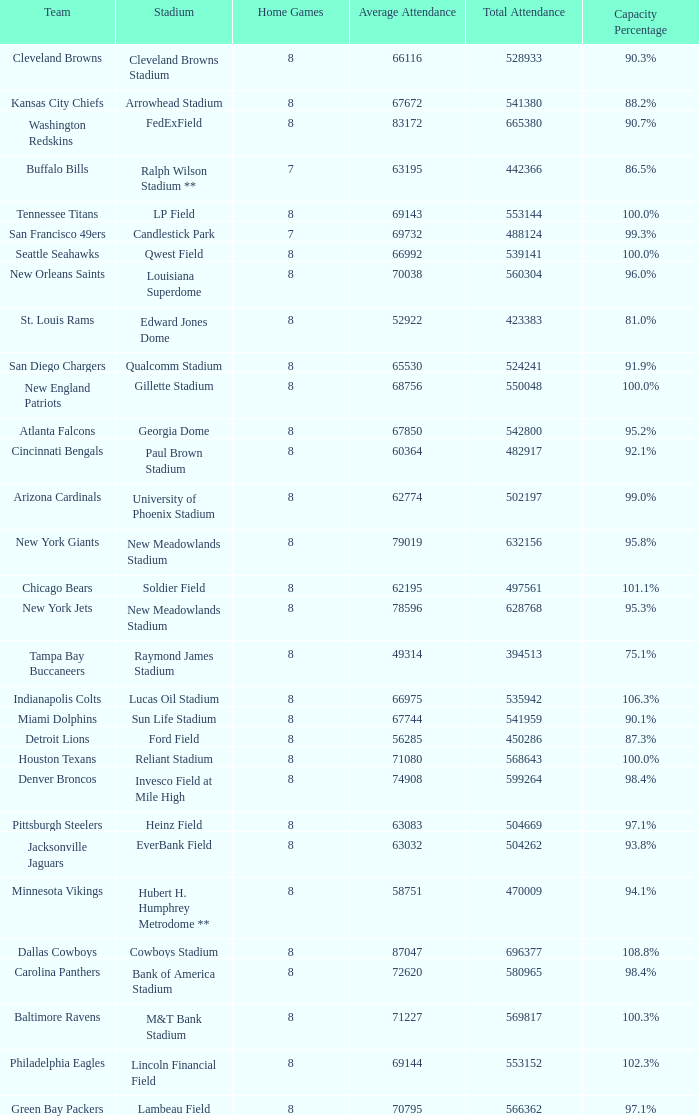Could you help me parse every detail presented in this table? {'header': ['Team', 'Stadium', 'Home Games', 'Average Attendance', 'Total Attendance', 'Capacity Percentage'], 'rows': [['Cleveland Browns', 'Cleveland Browns Stadium', '8', '66116', '528933', '90.3%'], ['Kansas City Chiefs', 'Arrowhead Stadium', '8', '67672', '541380', '88.2%'], ['Washington Redskins', 'FedExField', '8', '83172', '665380', '90.7%'], ['Buffalo Bills', 'Ralph Wilson Stadium **', '7', '63195', '442366', '86.5%'], ['Tennessee Titans', 'LP Field', '8', '69143', '553144', '100.0%'], ['San Francisco 49ers', 'Candlestick Park', '7', '69732', '488124', '99.3%'], ['Seattle Seahawks', 'Qwest Field', '8', '66992', '539141', '100.0%'], ['New Orleans Saints', 'Louisiana Superdome', '8', '70038', '560304', '96.0%'], ['St. Louis Rams', 'Edward Jones Dome', '8', '52922', '423383', '81.0%'], ['San Diego Chargers', 'Qualcomm Stadium', '8', '65530', '524241', '91.9%'], ['New England Patriots', 'Gillette Stadium', '8', '68756', '550048', '100.0%'], ['Atlanta Falcons', 'Georgia Dome', '8', '67850', '542800', '95.2%'], ['Cincinnati Bengals', 'Paul Brown Stadium', '8', '60364', '482917', '92.1%'], ['Arizona Cardinals', 'University of Phoenix Stadium', '8', '62774', '502197', '99.0%'], ['New York Giants', 'New Meadowlands Stadium', '8', '79019', '632156', '95.8%'], ['Chicago Bears', 'Soldier Field', '8', '62195', '497561', '101.1%'], ['New York Jets', 'New Meadowlands Stadium', '8', '78596', '628768', '95.3%'], ['Tampa Bay Buccaneers', 'Raymond James Stadium', '8', '49314', '394513', '75.1%'], ['Indianapolis Colts', 'Lucas Oil Stadium', '8', '66975', '535942', '106.3%'], ['Miami Dolphins', 'Sun Life Stadium', '8', '67744', '541959', '90.1%'], ['Detroit Lions', 'Ford Field', '8', '56285', '450286', '87.3%'], ['Houston Texans', 'Reliant Stadium', '8', '71080', '568643', '100.0%'], ['Denver Broncos', 'Invesco Field at Mile High', '8', '74908', '599264', '98.4%'], ['Pittsburgh Steelers', 'Heinz Field', '8', '63083', '504669', '97.1%'], ['Jacksonville Jaguars', 'EverBank Field', '8', '63032', '504262', '93.8%'], ['Minnesota Vikings', 'Hubert H. Humphrey Metrodome **', '8', '58751', '470009', '94.1%'], ['Dallas Cowboys', 'Cowboys Stadium', '8', '87047', '696377', '108.8%'], ['Carolina Panthers', 'Bank of America Stadium', '8', '72620', '580965', '98.4%'], ['Baltimore Ravens', 'M&T Bank Stadium', '8', '71227', '569817', '100.3%'], ['Philadelphia Eagles', 'Lincoln Financial Field', '8', '69144', '553152', '102.3%'], ['Green Bay Packers', 'Lambeau Field', '8', '70795', '566362', '97.1%']]} How many teams had a 99.3% capacity rating? 1.0. 